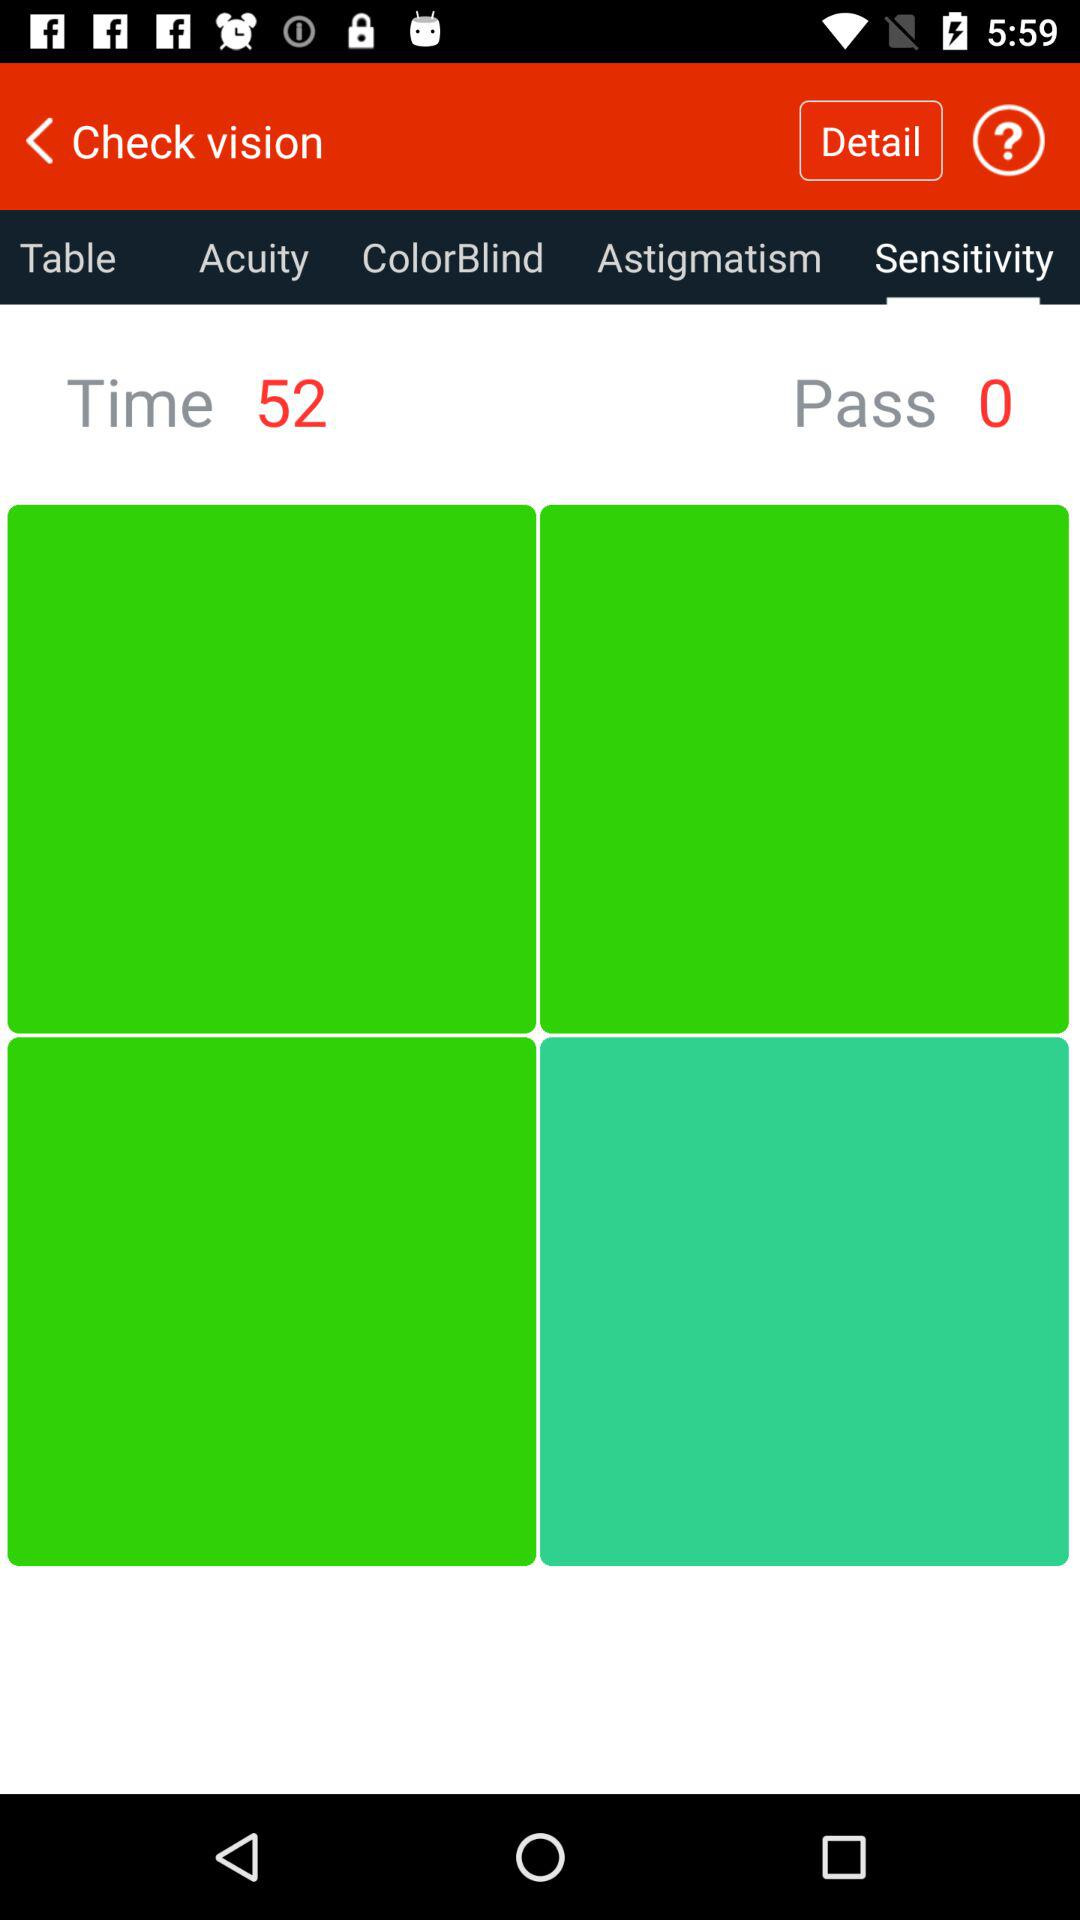How many "Pass" are there? There are 0 "Pass". 